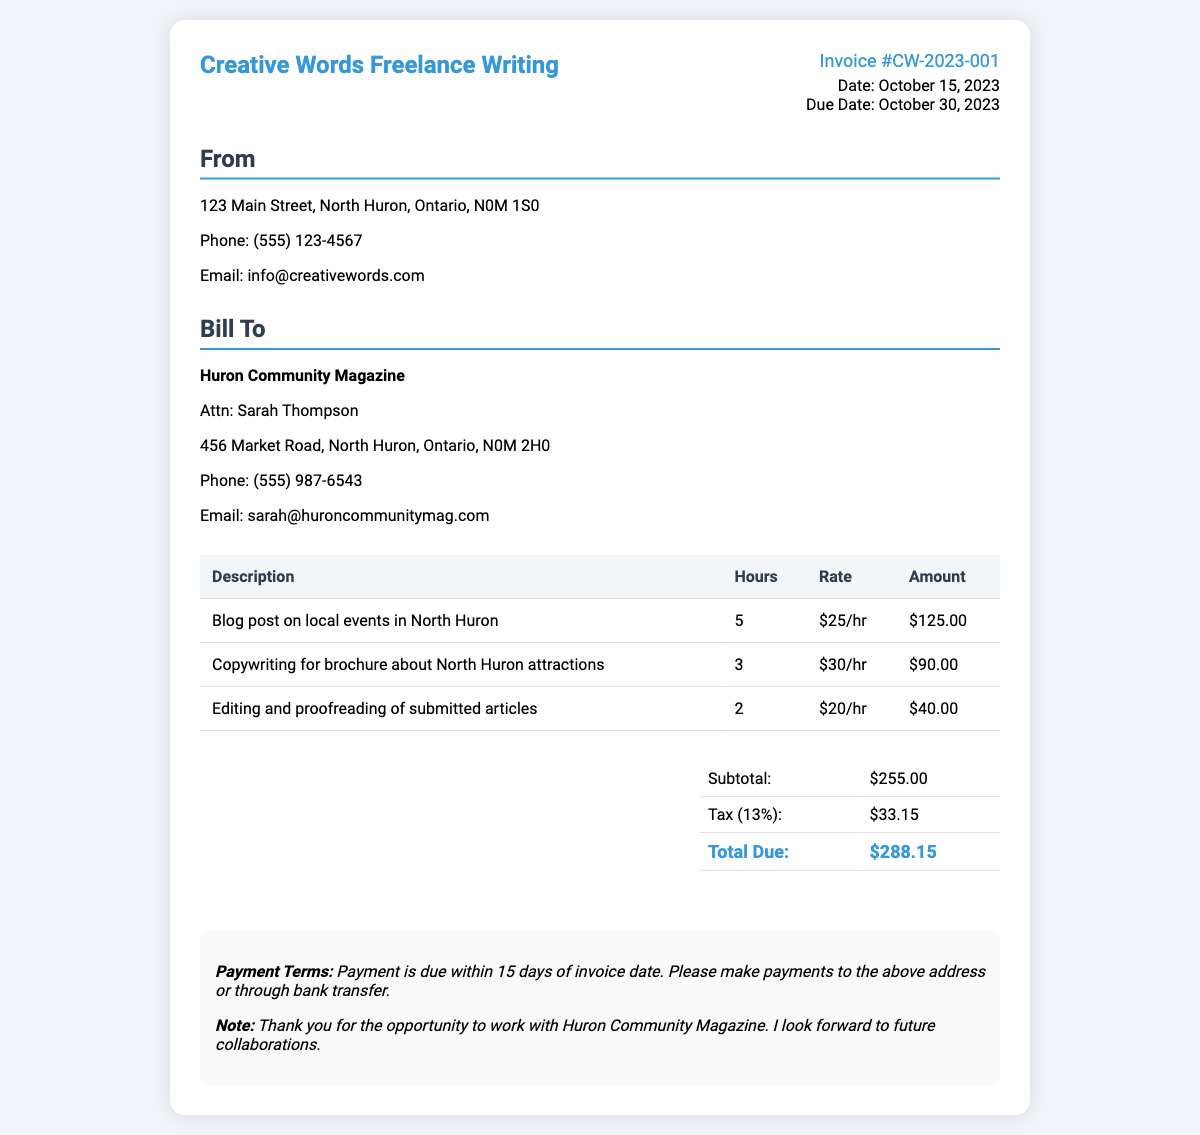What is the invoice number? The invoice number is provided in the invoice details section.
Answer: CW-2023-001 What is the total amount due? The total amount due is calculated at the bottom of the invoice in the total section.
Answer: $288.15 Who is the client for this invoice? The client information is listed under the "Bill To" section.
Answer: Huron Community Magazine How many hours were worked on the blog post? The hours worked on the blog post are specified in the services table.
Answer: 5 What is the tax rate applied to this invoice? The tax percentage is provided in the total section of the invoice.
Answer: 13% What services were provided? The services provided are listed in the description column of the services table.
Answer: Blog post, Copywriting, Editing What is the due date for payment? The due date is mentioned in the invoice details section.
Answer: October 30, 2023 What is the subtotal before tax? The subtotal is listed in the total section of the invoice.
Answer: $255.00 Who should payments be made to? The payment instructions would indicate who should receive the payments.
Answer: Creative Words Freelance Writing 